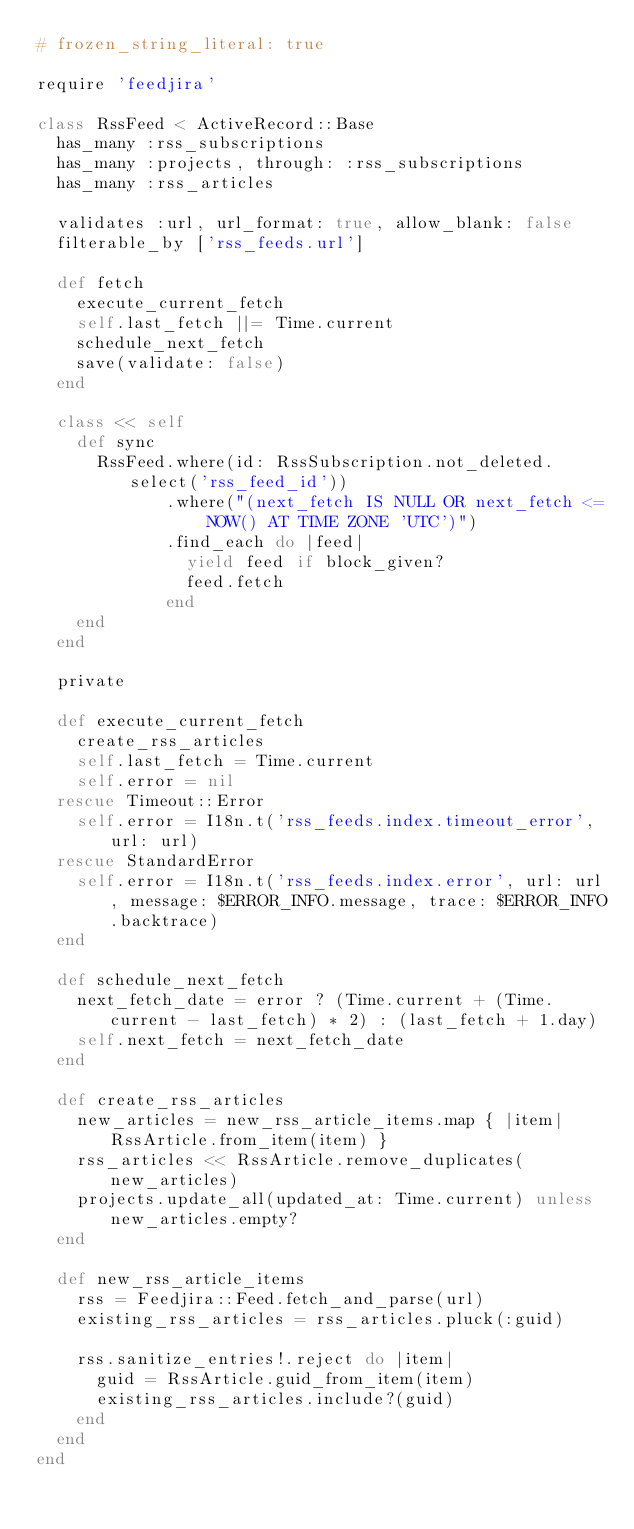Convert code to text. <code><loc_0><loc_0><loc_500><loc_500><_Ruby_># frozen_string_literal: true

require 'feedjira'

class RssFeed < ActiveRecord::Base
  has_many :rss_subscriptions
  has_many :projects, through: :rss_subscriptions
  has_many :rss_articles

  validates :url, url_format: true, allow_blank: false
  filterable_by ['rss_feeds.url']

  def fetch
    execute_current_fetch
    self.last_fetch ||= Time.current
    schedule_next_fetch
    save(validate: false)
  end

  class << self
    def sync
      RssFeed.where(id: RssSubscription.not_deleted.select('rss_feed_id'))
             .where("(next_fetch IS NULL OR next_fetch <= NOW() AT TIME ZONE 'UTC')")
             .find_each do |feed|
               yield feed if block_given?
               feed.fetch
             end
    end
  end

  private

  def execute_current_fetch
    create_rss_articles
    self.last_fetch = Time.current
    self.error = nil
  rescue Timeout::Error
    self.error = I18n.t('rss_feeds.index.timeout_error', url: url)
  rescue StandardError
    self.error = I18n.t('rss_feeds.index.error', url: url, message: $ERROR_INFO.message, trace: $ERROR_INFO.backtrace)
  end

  def schedule_next_fetch
    next_fetch_date = error ? (Time.current + (Time.current - last_fetch) * 2) : (last_fetch + 1.day)
    self.next_fetch = next_fetch_date
  end

  def create_rss_articles
    new_articles = new_rss_article_items.map { |item| RssArticle.from_item(item) }
    rss_articles << RssArticle.remove_duplicates(new_articles)
    projects.update_all(updated_at: Time.current) unless new_articles.empty?
  end

  def new_rss_article_items
    rss = Feedjira::Feed.fetch_and_parse(url)
    existing_rss_articles = rss_articles.pluck(:guid)

    rss.sanitize_entries!.reject do |item|
      guid = RssArticle.guid_from_item(item)
      existing_rss_articles.include?(guid)
    end
  end
end
</code> 